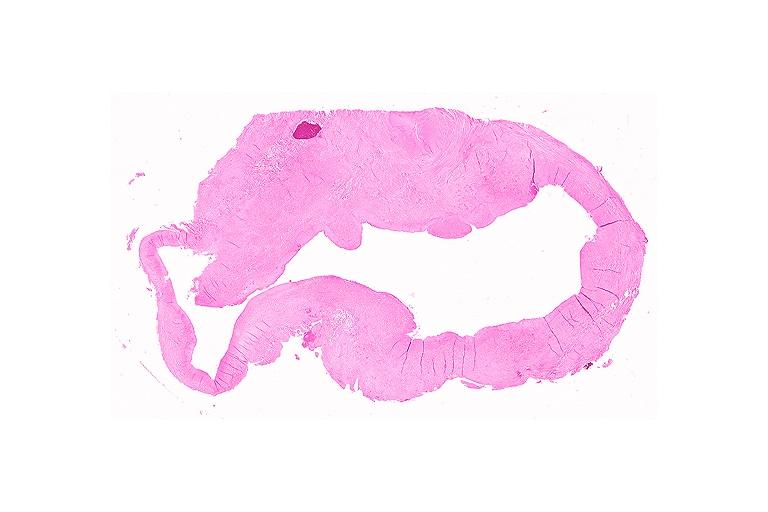where is this?
Answer the question using a single word or phrase. Oral 